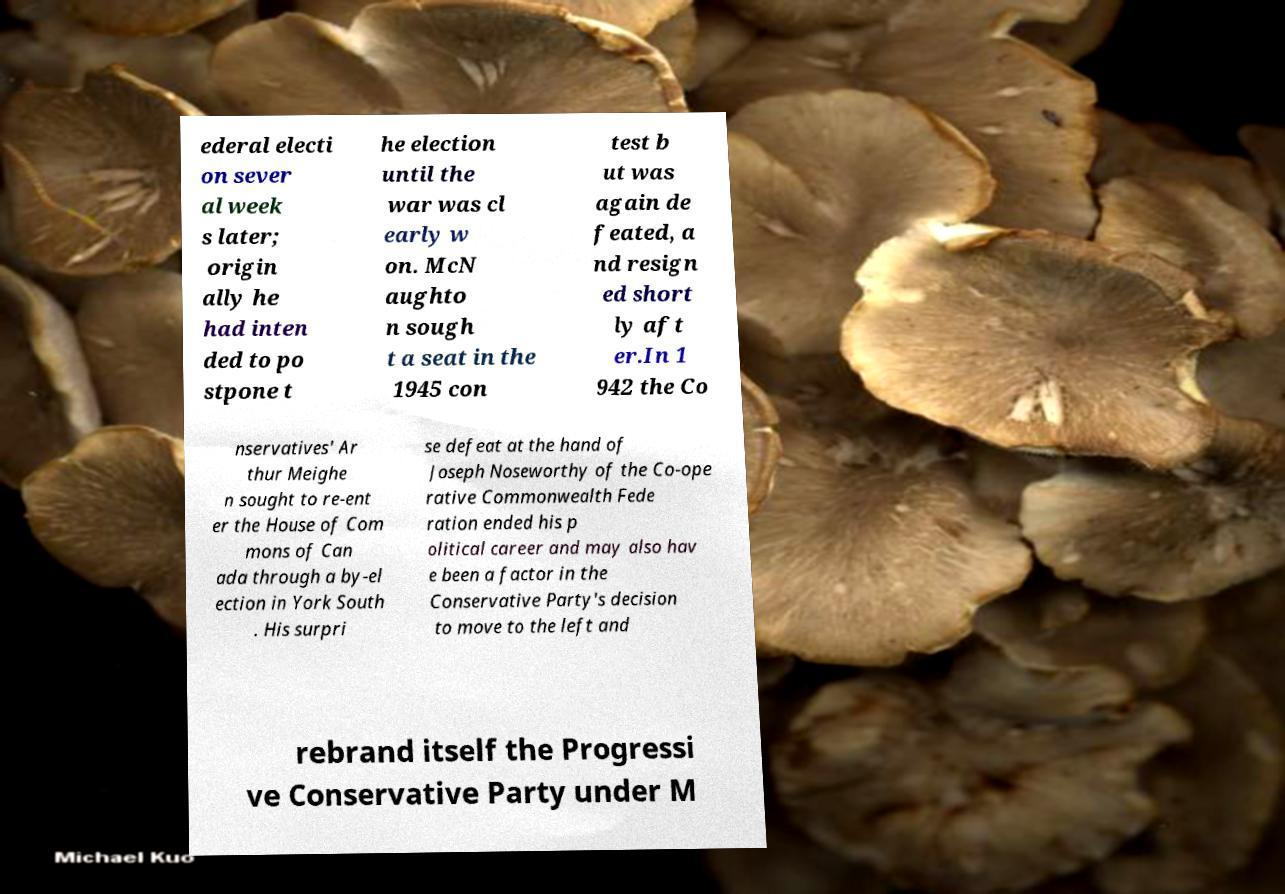There's text embedded in this image that I need extracted. Can you transcribe it verbatim? ederal electi on sever al week s later; origin ally he had inten ded to po stpone t he election until the war was cl early w on. McN aughto n sough t a seat in the 1945 con test b ut was again de feated, a nd resign ed short ly aft er.In 1 942 the Co nservatives' Ar thur Meighe n sought to re-ent er the House of Com mons of Can ada through a by-el ection in York South . His surpri se defeat at the hand of Joseph Noseworthy of the Co-ope rative Commonwealth Fede ration ended his p olitical career and may also hav e been a factor in the Conservative Party's decision to move to the left and rebrand itself the Progressi ve Conservative Party under M 